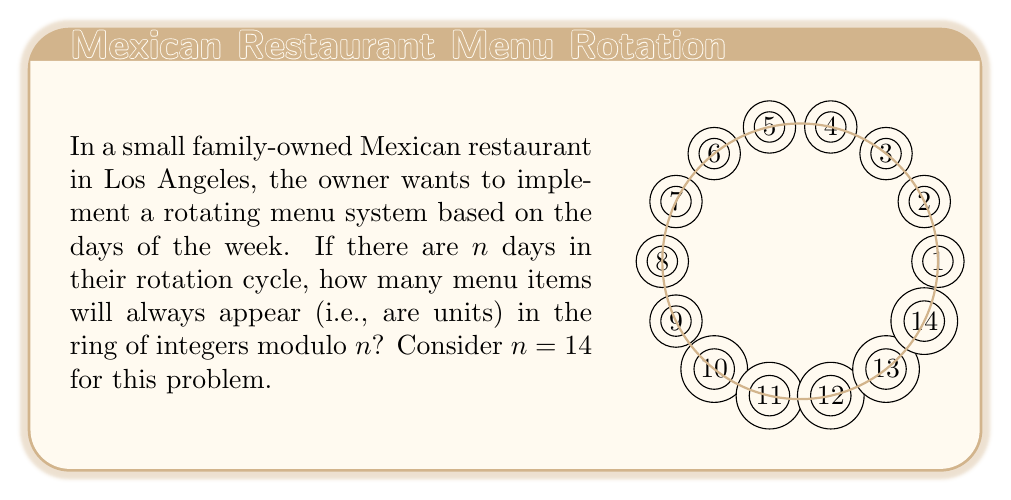Teach me how to tackle this problem. To solve this problem, we need to understand the concept of units in the ring of integers modulo $n$.

1) In the ring of integers modulo $n$, denoted as $\mathbb{Z}_n$, an element $a$ is a unit if there exists an element $b$ such that $ab \equiv 1 \pmod{n}$.

2) This is equivalent to saying that $a$ and $n$ are coprime, i.e., their greatest common divisor is 1: $\gcd(a,n) = 1$.

3) For $n = 14$, we need to count how many numbers from 1 to 13 are coprime to 14.

4) To find this, let's list out the factors of 14: 1, 2, 7, 14.

5) The numbers from 1 to 13 that are not coprime to 14 are: 2, 7.

6) Therefore, the numbers that are coprime to 14 are: 1, 3, 5, 9, 11, 13.

7) We can verify this by checking that each of these numbers, when multiplied by some other number modulo 14, gives a remainder of 1.

8) The count of these numbers is given by the Euler totient function $\phi(14)$.

9) For prime factors $p$ and $q$, $\phi(pq) = (p-1)(q-1)$. Here, $14 = 2 \times 7$.

10) So, $\phi(14) = (2-1)(7-1) = 1 \times 6 = 6$.

Therefore, there are 6 units in the ring of integers modulo 14.
Answer: $\phi(14) = 6$ 